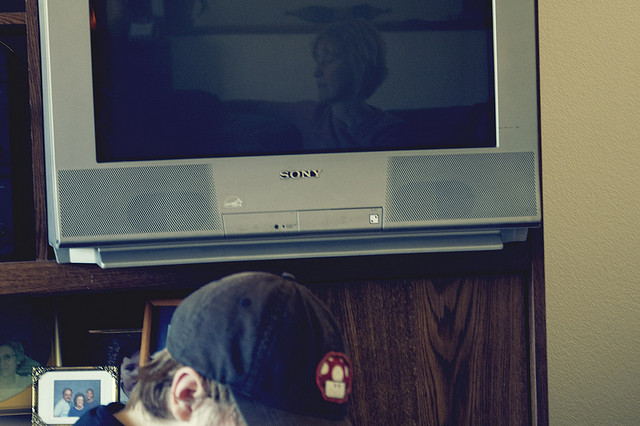<image>What is the man doing? I am not sure what the man is doing. He could be reading, looking down or sitting. Figure out what the sign say based on the partial letters visible? I am unsure what the sign says based on the partial letters visible. It might be 'sony'. What is the man doing? I am not sure what the man is doing. He can be either reading or looking down. Figure out what the sign say based on the partial letters visible? It is ambiguous what the sign says based on the partial letters visible. It can be seen 'sony' or 'unsure'. 